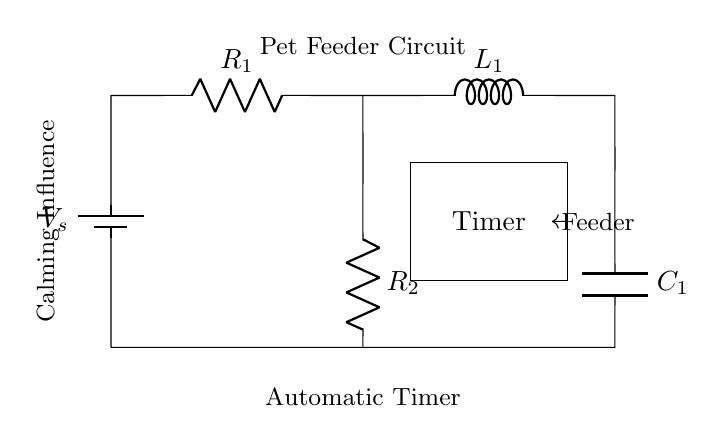What is the type of this circuit? This circuit is a series-parallel RLC circuit because it contains a combination of resistors, an inductor, and a capacitor arranged in series and parallel configurations.
Answer: series-parallel RLC circuit What components are connected in series? To determine the components in series, we look at the path from the battery through R1, L1, and then down to C1. All these components share a common current path without branching.
Answer: R1, L1, C1 What is the role of the timer in the circuit? The timer controls the feeder which indicates that it is likely used to manage the timing of when the pet feeder dispenses food. It is a critical component for automation in this circuit setup.
Answer: Feeder timing How many resistors are present in the circuit? By examining the diagram, we see there are two resistors labeled R1 and R2, indicating there are a total of two resistors present in the circuit.
Answer: 2 What would happen if the capacitor is disconnected? If C1 is disconnected, it would disrupt the energy storage capability in the circuit, potentially affecting the timing function of the automatic timer and altering current flow, which could affect the pet feeder's operation.
Answer: Disrupt function Which component provides inductive reactance in this circuit? The inductor labeled L1 is responsible for providing inductive reactance, which opposes changes in current and affects the circuit's overall impedance in response to AC signals.
Answer: L1 What is the function of the battery in this circuit? The battery supplies the necessary voltage (energy) to the entire circuit, enabling the components to function (including the timer and feeder). It acts as the power source for the circuit.
Answer: Power source 